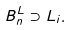Convert formula to latex. <formula><loc_0><loc_0><loc_500><loc_500>B ^ { L } _ { n } \supset L _ { i } .</formula> 